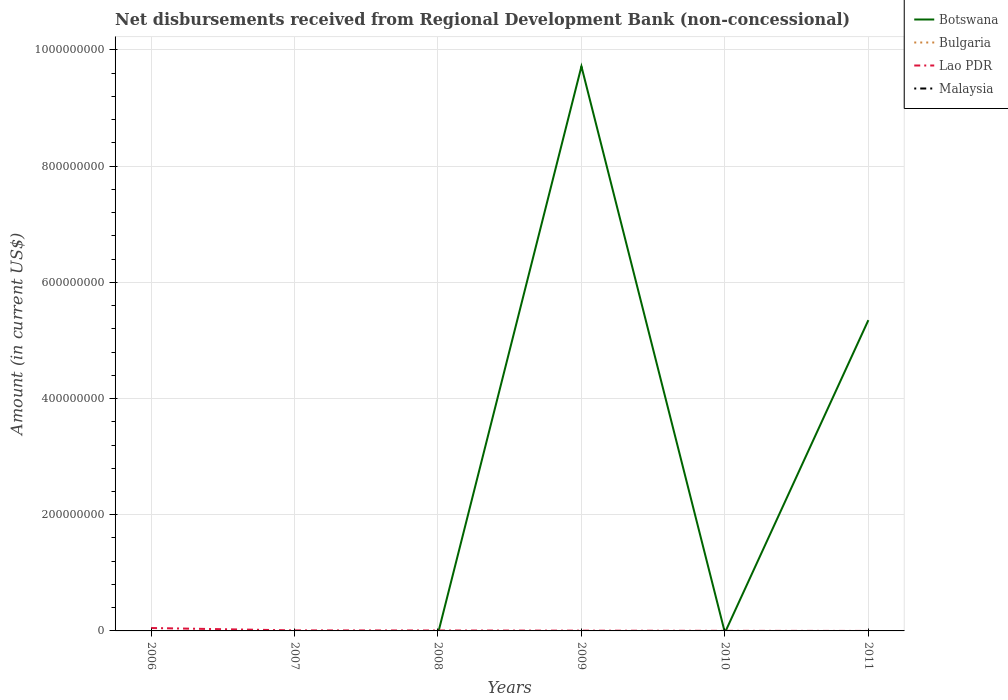Across all years, what is the maximum amount of disbursements received from Regional Development Bank in Botswana?
Keep it short and to the point. 0. What is the difference between the highest and the second highest amount of disbursements received from Regional Development Bank in Botswana?
Ensure brevity in your answer.  9.72e+08. What is the difference between the highest and the lowest amount of disbursements received from Regional Development Bank in Bulgaria?
Your answer should be compact. 0. How many lines are there?
Make the answer very short. 2. What is the difference between two consecutive major ticks on the Y-axis?
Ensure brevity in your answer.  2.00e+08. Are the values on the major ticks of Y-axis written in scientific E-notation?
Keep it short and to the point. No. Does the graph contain any zero values?
Offer a very short reply. Yes. Does the graph contain grids?
Make the answer very short. Yes. How are the legend labels stacked?
Provide a succinct answer. Vertical. What is the title of the graph?
Your answer should be compact. Net disbursements received from Regional Development Bank (non-concessional). What is the label or title of the X-axis?
Make the answer very short. Years. What is the Amount (in current US$) of Botswana in 2006?
Offer a terse response. 0. What is the Amount (in current US$) in Lao PDR in 2006?
Your answer should be compact. 4.99e+06. What is the Amount (in current US$) in Bulgaria in 2007?
Offer a very short reply. 0. What is the Amount (in current US$) in Lao PDR in 2007?
Make the answer very short. 9.09e+05. What is the Amount (in current US$) of Malaysia in 2007?
Give a very brief answer. 0. What is the Amount (in current US$) of Botswana in 2008?
Your response must be concise. 0. What is the Amount (in current US$) in Lao PDR in 2008?
Offer a terse response. 7.44e+05. What is the Amount (in current US$) in Malaysia in 2008?
Your answer should be compact. 0. What is the Amount (in current US$) in Botswana in 2009?
Ensure brevity in your answer.  9.72e+08. What is the Amount (in current US$) in Lao PDR in 2009?
Provide a short and direct response. 4.51e+05. What is the Amount (in current US$) in Botswana in 2010?
Ensure brevity in your answer.  0. What is the Amount (in current US$) in Lao PDR in 2010?
Provide a short and direct response. 1.52e+05. What is the Amount (in current US$) in Botswana in 2011?
Provide a succinct answer. 5.35e+08. What is the Amount (in current US$) in Bulgaria in 2011?
Give a very brief answer. 0. What is the Amount (in current US$) in Lao PDR in 2011?
Provide a succinct answer. 0. Across all years, what is the maximum Amount (in current US$) in Botswana?
Make the answer very short. 9.72e+08. Across all years, what is the maximum Amount (in current US$) in Lao PDR?
Your response must be concise. 4.99e+06. Across all years, what is the minimum Amount (in current US$) in Botswana?
Provide a short and direct response. 0. Across all years, what is the minimum Amount (in current US$) in Lao PDR?
Keep it short and to the point. 0. What is the total Amount (in current US$) in Botswana in the graph?
Your answer should be very brief. 1.51e+09. What is the total Amount (in current US$) in Lao PDR in the graph?
Provide a succinct answer. 7.24e+06. What is the total Amount (in current US$) in Malaysia in the graph?
Provide a succinct answer. 0. What is the difference between the Amount (in current US$) of Lao PDR in 2006 and that in 2007?
Make the answer very short. 4.08e+06. What is the difference between the Amount (in current US$) of Lao PDR in 2006 and that in 2008?
Keep it short and to the point. 4.24e+06. What is the difference between the Amount (in current US$) in Lao PDR in 2006 and that in 2009?
Keep it short and to the point. 4.54e+06. What is the difference between the Amount (in current US$) of Lao PDR in 2006 and that in 2010?
Keep it short and to the point. 4.84e+06. What is the difference between the Amount (in current US$) in Lao PDR in 2007 and that in 2008?
Your answer should be very brief. 1.65e+05. What is the difference between the Amount (in current US$) in Lao PDR in 2007 and that in 2009?
Ensure brevity in your answer.  4.58e+05. What is the difference between the Amount (in current US$) in Lao PDR in 2007 and that in 2010?
Provide a short and direct response. 7.57e+05. What is the difference between the Amount (in current US$) in Lao PDR in 2008 and that in 2009?
Offer a very short reply. 2.93e+05. What is the difference between the Amount (in current US$) in Lao PDR in 2008 and that in 2010?
Offer a terse response. 5.92e+05. What is the difference between the Amount (in current US$) of Lao PDR in 2009 and that in 2010?
Ensure brevity in your answer.  2.99e+05. What is the difference between the Amount (in current US$) in Botswana in 2009 and that in 2011?
Offer a very short reply. 4.37e+08. What is the difference between the Amount (in current US$) of Botswana in 2009 and the Amount (in current US$) of Lao PDR in 2010?
Your answer should be very brief. 9.72e+08. What is the average Amount (in current US$) of Botswana per year?
Provide a succinct answer. 2.51e+08. What is the average Amount (in current US$) in Bulgaria per year?
Provide a succinct answer. 0. What is the average Amount (in current US$) in Lao PDR per year?
Your answer should be very brief. 1.21e+06. In the year 2009, what is the difference between the Amount (in current US$) of Botswana and Amount (in current US$) of Lao PDR?
Give a very brief answer. 9.71e+08. What is the ratio of the Amount (in current US$) in Lao PDR in 2006 to that in 2007?
Your answer should be compact. 5.49. What is the ratio of the Amount (in current US$) in Lao PDR in 2006 to that in 2008?
Offer a very short reply. 6.71. What is the ratio of the Amount (in current US$) of Lao PDR in 2006 to that in 2009?
Your response must be concise. 11.06. What is the ratio of the Amount (in current US$) in Lao PDR in 2006 to that in 2010?
Your answer should be very brief. 32.82. What is the ratio of the Amount (in current US$) of Lao PDR in 2007 to that in 2008?
Keep it short and to the point. 1.22. What is the ratio of the Amount (in current US$) of Lao PDR in 2007 to that in 2009?
Your response must be concise. 2.02. What is the ratio of the Amount (in current US$) in Lao PDR in 2007 to that in 2010?
Your answer should be compact. 5.98. What is the ratio of the Amount (in current US$) of Lao PDR in 2008 to that in 2009?
Make the answer very short. 1.65. What is the ratio of the Amount (in current US$) of Lao PDR in 2008 to that in 2010?
Provide a short and direct response. 4.89. What is the ratio of the Amount (in current US$) of Lao PDR in 2009 to that in 2010?
Your response must be concise. 2.97. What is the ratio of the Amount (in current US$) in Botswana in 2009 to that in 2011?
Make the answer very short. 1.82. What is the difference between the highest and the second highest Amount (in current US$) in Lao PDR?
Your response must be concise. 4.08e+06. What is the difference between the highest and the lowest Amount (in current US$) of Botswana?
Give a very brief answer. 9.72e+08. What is the difference between the highest and the lowest Amount (in current US$) in Lao PDR?
Give a very brief answer. 4.99e+06. 